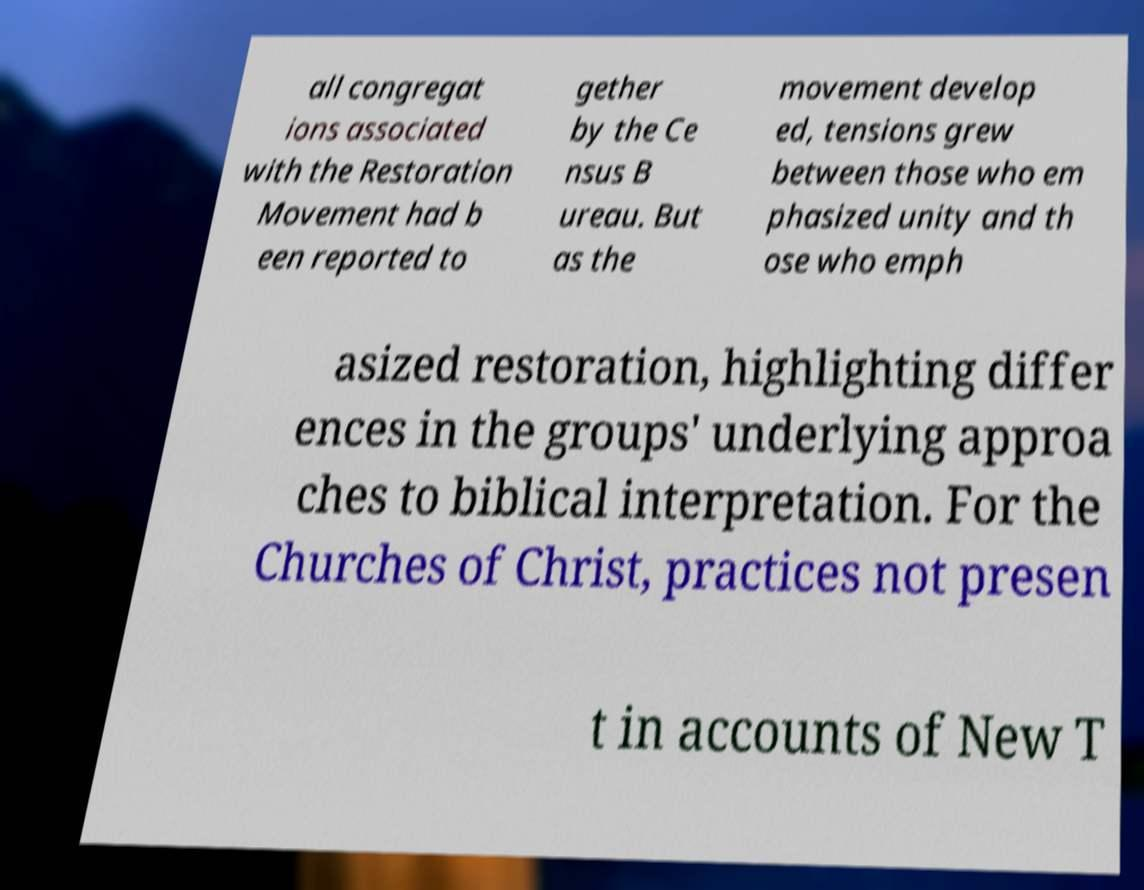Please read and relay the text visible in this image. What does it say? all congregat ions associated with the Restoration Movement had b een reported to gether by the Ce nsus B ureau. But as the movement develop ed, tensions grew between those who em phasized unity and th ose who emph asized restoration, highlighting differ ences in the groups' underlying approa ches to biblical interpretation. For the Churches of Christ, practices not presen t in accounts of New T 